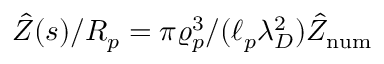<formula> <loc_0><loc_0><loc_500><loc_500>\hat { Z } ( s ) / R _ { p } = \pi \varrho _ { p } ^ { 3 } / ( \ell _ { p } \lambda _ { D } ^ { 2 } ) \hat { Z } _ { n u m }</formula> 